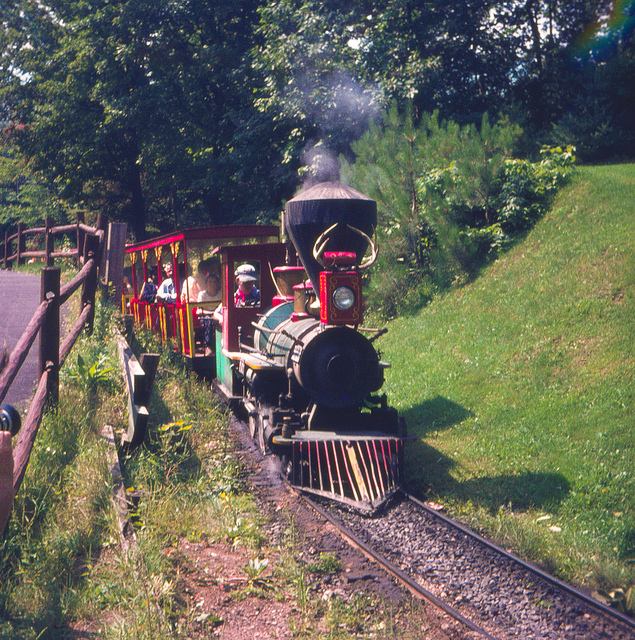<image>Where is this train going? It is unknown where this train is going. It could be going around a park, to a station, or even an amusement park. Where is this train going? It is ambiguous where this train is going. It can be going around the park, to the station, or in a circle. 